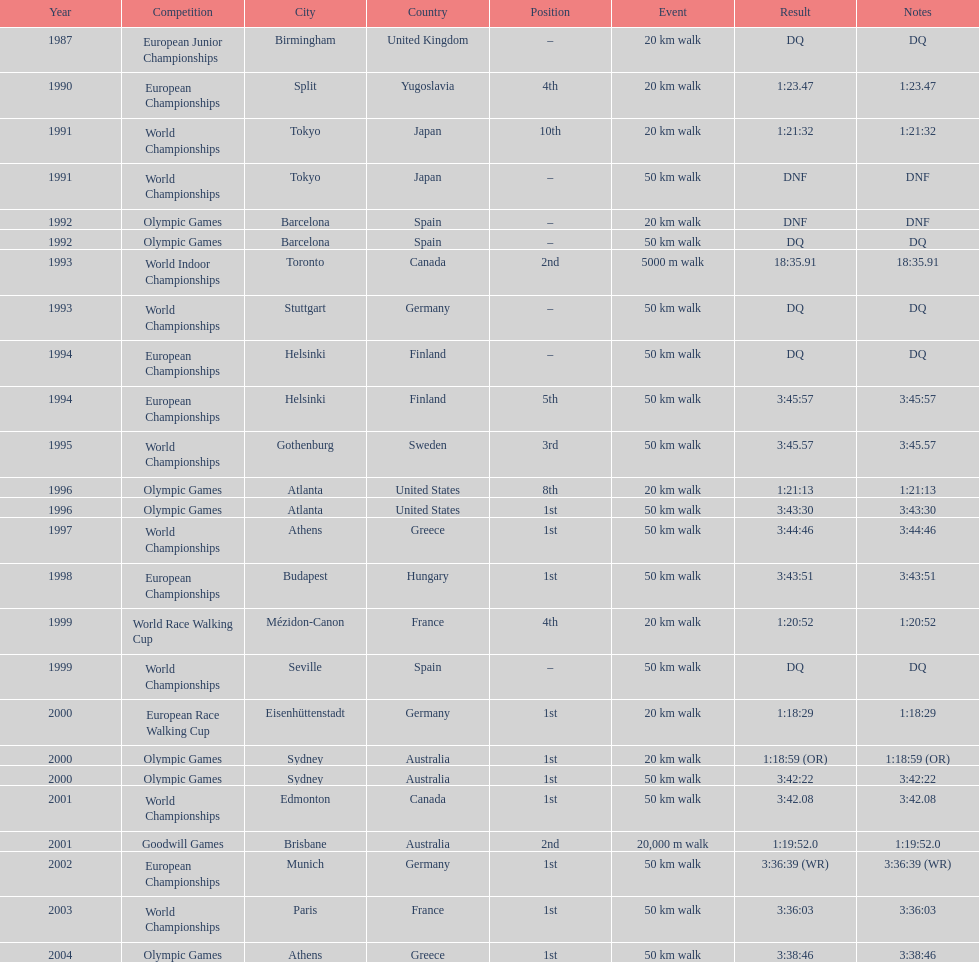How many times was korzeniowski disqualified from a competition? 5. 